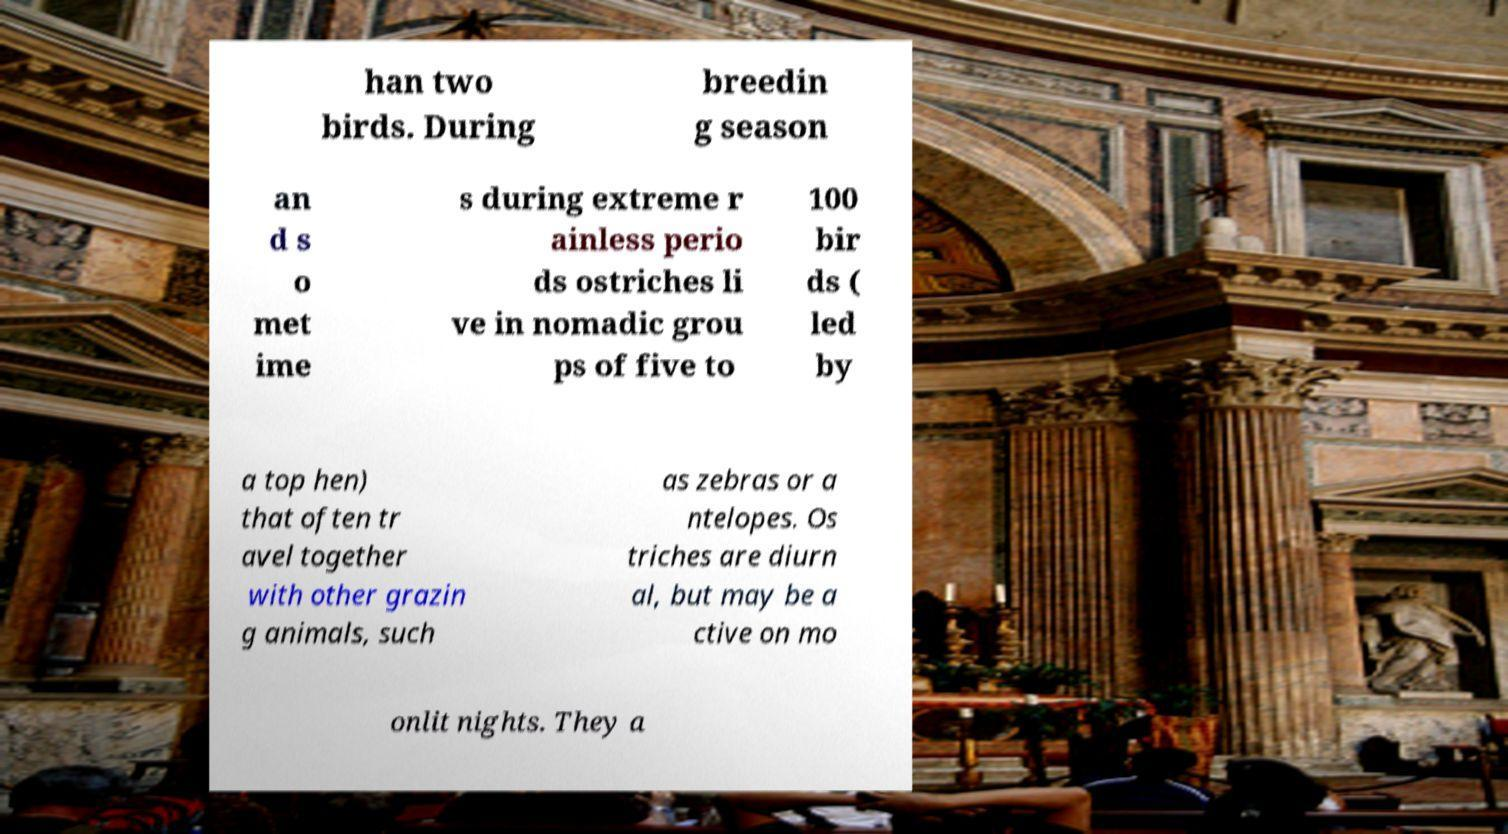There's text embedded in this image that I need extracted. Can you transcribe it verbatim? han two birds. During breedin g season an d s o met ime s during extreme r ainless perio ds ostriches li ve in nomadic grou ps of five to 100 bir ds ( led by a top hen) that often tr avel together with other grazin g animals, such as zebras or a ntelopes. Os triches are diurn al, but may be a ctive on mo onlit nights. They a 